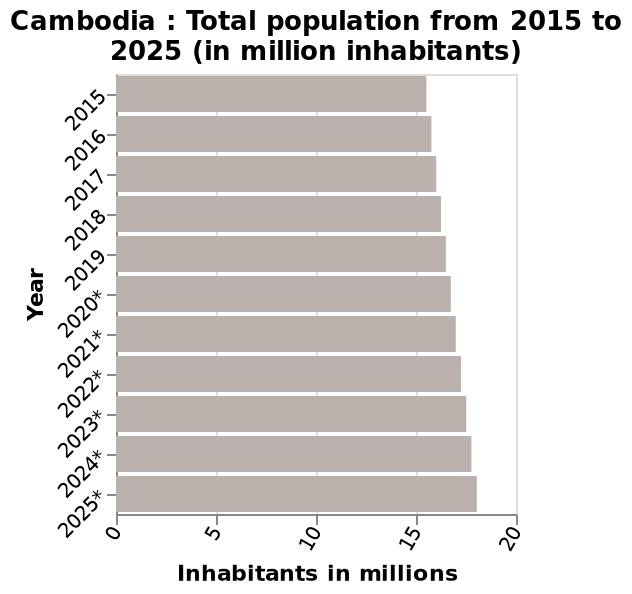<image>
What is the minimum value on the x-axis in the bar diagram? The minimum value on the x-axis is 0 million inhabitants. What is the maximum value on the x-axis in the bar diagram? The maximum value on the x-axis is 20 million inhabitants. please enumerates aspects of the construction of the chart This bar diagram is titled Cambodia : Total population from 2015 to 2025 (in million inhabitants). The x-axis plots Inhabitants in millions using linear scale with a minimum of 0 and a maximum of 20 while the y-axis shows Year using categorical scale from 2015 to 2025*. 